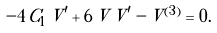Convert formula to latex. <formula><loc_0><loc_0><loc_500><loc_500>- 4 \, { C _ { 1 } } \, V ^ { \prime } + 6 \, V \, V ^ { \prime } - V ^ { ( 3 ) } = 0 .</formula> 